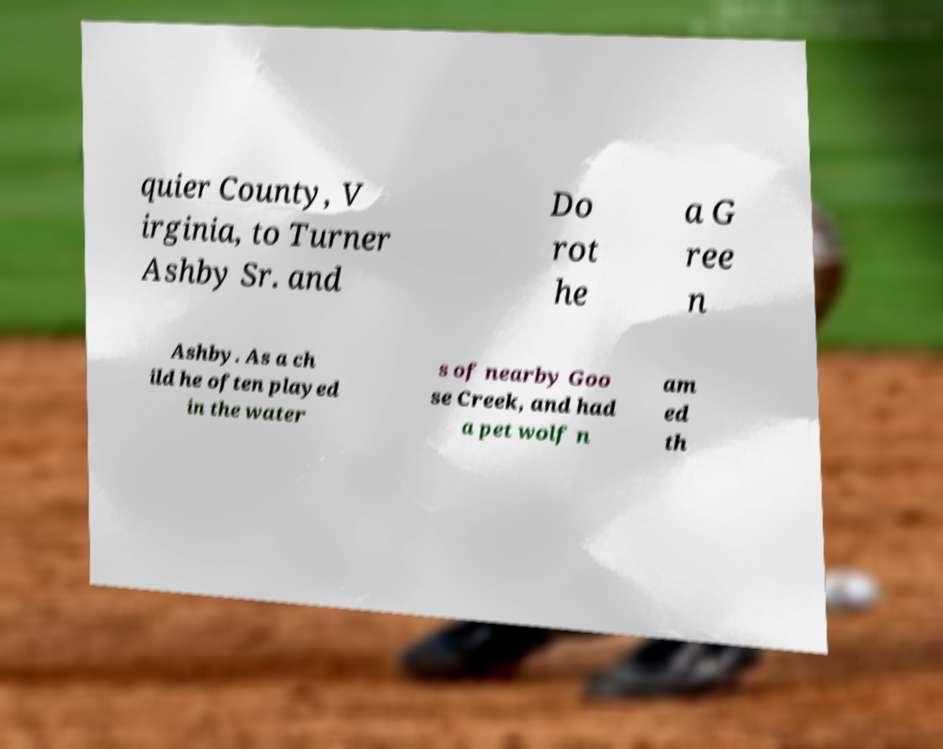What messages or text are displayed in this image? I need them in a readable, typed format. quier County, V irginia, to Turner Ashby Sr. and Do rot he a G ree n Ashby. As a ch ild he often played in the water s of nearby Goo se Creek, and had a pet wolf n am ed th 